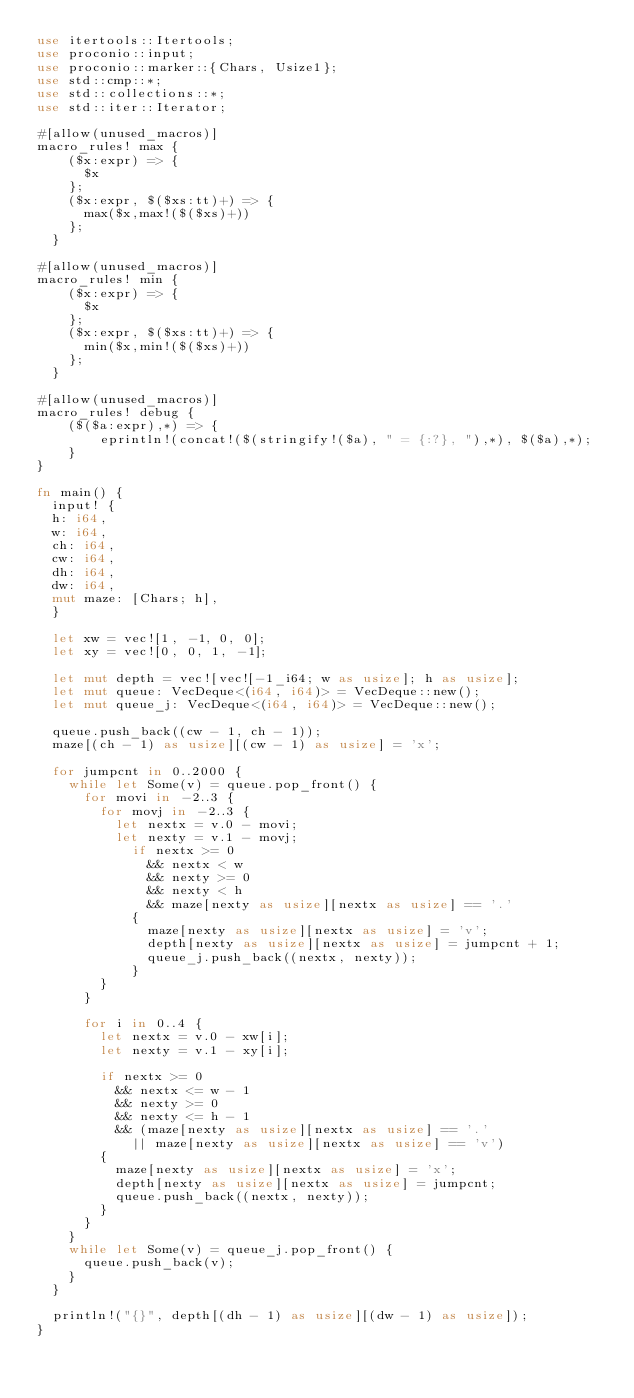Convert code to text. <code><loc_0><loc_0><loc_500><loc_500><_Rust_>use itertools::Itertools;
use proconio::input;
use proconio::marker::{Chars, Usize1};
use std::cmp::*;
use std::collections::*;
use std::iter::Iterator;

#[allow(unused_macros)]
macro_rules! max {
    ($x:expr) => {
      $x
    };
    ($x:expr, $($xs:tt)+) => {
      max($x,max!($($xs)+))
    };
  }

#[allow(unused_macros)]
macro_rules! min {
    ($x:expr) => {
      $x
    };
    ($x:expr, $($xs:tt)+) => {
      min($x,min!($($xs)+))
    };
  }

#[allow(unused_macros)]
macro_rules! debug {
    ($($a:expr),*) => {
        eprintln!(concat!($(stringify!($a), " = {:?}, "),*), $($a),*);
    }
}

fn main() {
  input! {
  h: i64,
  w: i64,
  ch: i64,
  cw: i64,
  dh: i64,
  dw: i64,
  mut maze: [Chars; h],
  }

  let xw = vec![1, -1, 0, 0];
  let xy = vec![0, 0, 1, -1];

  let mut depth = vec![vec![-1_i64; w as usize]; h as usize];
  let mut queue: VecDeque<(i64, i64)> = VecDeque::new();
  let mut queue_j: VecDeque<(i64, i64)> = VecDeque::new();

  queue.push_back((cw - 1, ch - 1));
  maze[(ch - 1) as usize][(cw - 1) as usize] = 'x';

  for jumpcnt in 0..2000 {
    while let Some(v) = queue.pop_front() {
      for movi in -2..3 {
        for movj in -2..3 {
          let nextx = v.0 - movi;
          let nexty = v.1 - movj;
            if nextx >= 0
              && nextx < w
              && nexty >= 0
              && nexty < h
              && maze[nexty as usize][nextx as usize] == '.'
            {
              maze[nexty as usize][nextx as usize] = 'v';
              depth[nexty as usize][nextx as usize] = jumpcnt + 1;
              queue_j.push_back((nextx, nexty));
            }
        }
      }

      for i in 0..4 {
        let nextx = v.0 - xw[i];
        let nexty = v.1 - xy[i];

        if nextx >= 0
          && nextx <= w - 1
          && nexty >= 0
          && nexty <= h - 1
          && (maze[nexty as usize][nextx as usize] == '.'
            || maze[nexty as usize][nextx as usize] == 'v')
        {
          maze[nexty as usize][nextx as usize] = 'x';
          depth[nexty as usize][nextx as usize] = jumpcnt;
          queue.push_back((nextx, nexty));
        }
      }
    }
    while let Some(v) = queue_j.pop_front() {
      queue.push_back(v);
    }
  }

  println!("{}", depth[(dh - 1) as usize][(dw - 1) as usize]);
}
</code> 